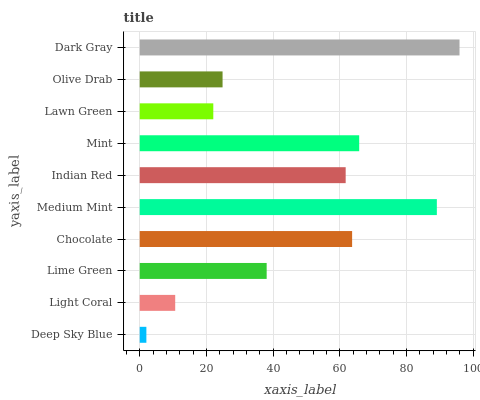Is Deep Sky Blue the minimum?
Answer yes or no. Yes. Is Dark Gray the maximum?
Answer yes or no. Yes. Is Light Coral the minimum?
Answer yes or no. No. Is Light Coral the maximum?
Answer yes or no. No. Is Light Coral greater than Deep Sky Blue?
Answer yes or no. Yes. Is Deep Sky Blue less than Light Coral?
Answer yes or no. Yes. Is Deep Sky Blue greater than Light Coral?
Answer yes or no. No. Is Light Coral less than Deep Sky Blue?
Answer yes or no. No. Is Indian Red the high median?
Answer yes or no. Yes. Is Lime Green the low median?
Answer yes or no. Yes. Is Chocolate the high median?
Answer yes or no. No. Is Deep Sky Blue the low median?
Answer yes or no. No. 